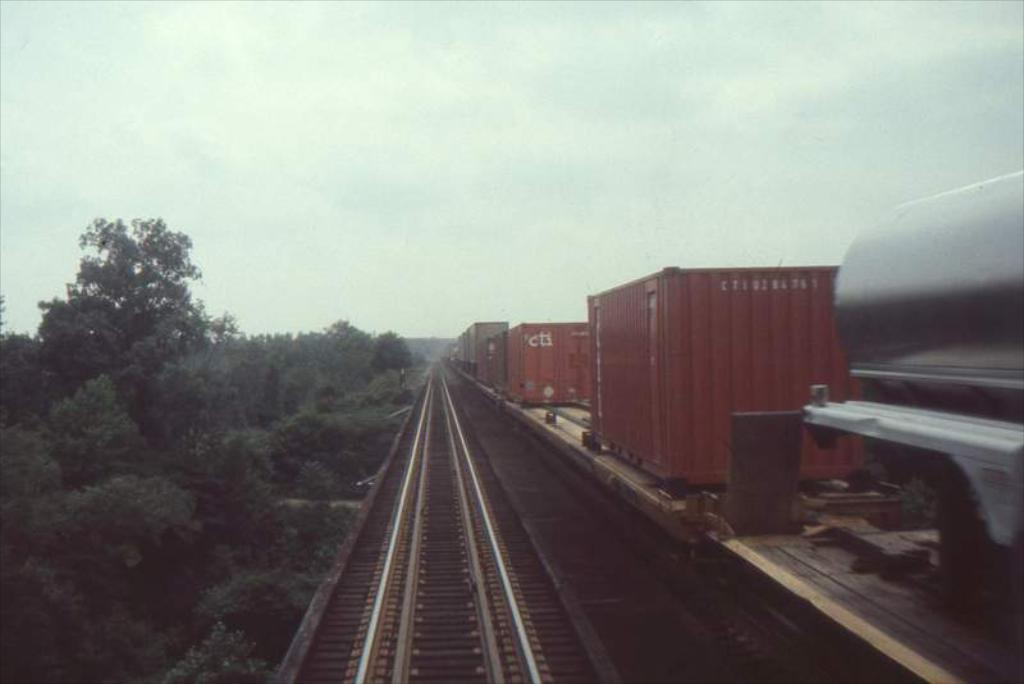What type of train is on the track in the image? There is a goods train on the track in the image. What can be seen running alongside the train track? The train track is visible in the image. What type of vegetation is present in the image? There are plants and trees in the image. What time is the sofa depicted in the image? There is no sofa present in the image. What riddle can be solved by looking at the trees in the image? There is no riddle associated with the trees in the image. 